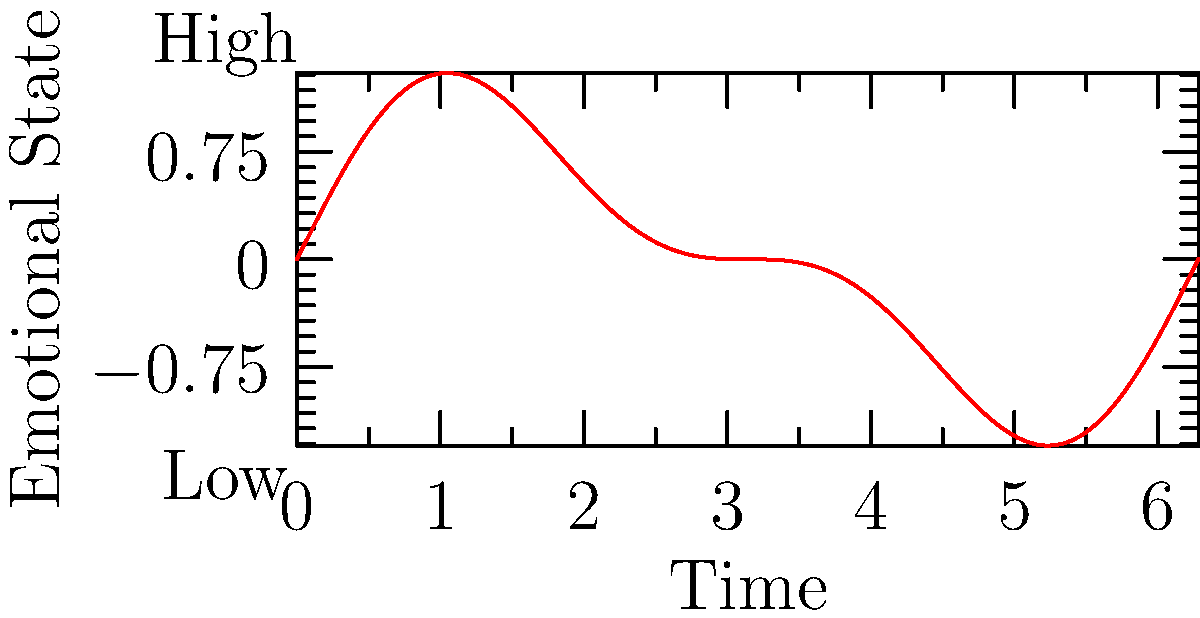Analyzing the emotion fluctuation graph over time, what pattern emerges that might indicate a cycle of emotional abuse and recovery? To identify patterns in this emotion fluctuation graph:

1. Observe the overall shape: The graph shows a sinusoidal pattern with smaller fluctuations superimposed.

2. Interpret the y-axis: It represents emotional state, with higher values indicating more positive emotions and lower values indicating more negative emotions.

3. Analyze the main wave:
   a. The large peaks represent periods of high emotional state, possibly associated with reconciliation or "honeymoon" phases in an abusive cycle.
   b. The large troughs represent periods of low emotional state, possibly associated with abusive episodes.

4. Examine the smaller fluctuations:
   a. These could represent daily emotional variations or responses to minor events.
   b. They are superimposed on the larger cycle, suggesting ongoing emotional instability even during "better" periods.

5. Consider the repetitive nature:
   The pattern repeats, indicating a cycle that continues over time, typical of abusive relationships.

6. Reflect on recovery:
   The graph shows a return to higher emotional states after lows, which could represent resilience and efforts to overcome the abuse.

This pattern is consistent with the cycle of abuse: tension building, acute incident, reconciliation, and calm, repeating over time. The gradual return to positive states after lows could indicate the process of overcoming the abusive relationship.
Answer: Cyclic pattern of highs and lows with superimposed smaller fluctuations, indicating abuse cycles and recovery efforts. 